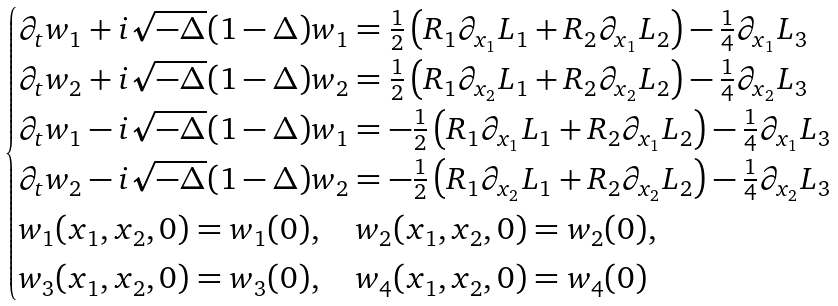<formula> <loc_0><loc_0><loc_500><loc_500>\begin{cases} \partial _ { t } w _ { 1 } + i \sqrt { - \Delta } ( 1 - \Delta ) w _ { 1 } = \frac { 1 } { 2 } \left ( R _ { 1 } \partial _ { x _ { 1 } } L _ { 1 } + R _ { 2 } \partial _ { x _ { 1 } } L _ { 2 } \right ) - \frac { 1 } { 4 } \partial _ { x _ { 1 } } L _ { 3 } \\ \partial _ { t } w _ { 2 } + i \sqrt { - \Delta } ( 1 - \Delta ) w _ { 2 } = \frac { 1 } { 2 } \left ( R _ { 1 } \partial _ { x _ { 2 } } L _ { 1 } + R _ { 2 } \partial _ { x _ { 2 } } L _ { 2 } \right ) - \frac { 1 } { 4 } \partial _ { x _ { 2 } } L _ { 3 } \\ \partial _ { t } w _ { 1 } - i \sqrt { - \Delta } ( 1 - \Delta ) w _ { 1 } = - \frac { 1 } { 2 } \left ( R _ { 1 } \partial _ { x _ { 1 } } L _ { 1 } + R _ { 2 } \partial _ { x _ { 1 } } L _ { 2 } \right ) - \frac { 1 } { 4 } \partial _ { x _ { 1 } } L _ { 3 } \\ \partial _ { t } w _ { 2 } - i \sqrt { - \Delta } ( 1 - \Delta ) w _ { 2 } = - \frac { 1 } { 2 } \left ( R _ { 1 } \partial _ { x _ { 2 } } L _ { 1 } + R _ { 2 } \partial _ { x _ { 2 } } L _ { 2 } \right ) - \frac { 1 } { 4 } \partial _ { x _ { 2 } } L _ { 3 } \\ w _ { 1 } ( x _ { 1 } , x _ { 2 } , 0 ) = w _ { 1 } ( 0 ) , \quad w _ { 2 } ( x _ { 1 } , x _ { 2 } , 0 ) = w _ { 2 } ( 0 ) , \\ w _ { 3 } ( x _ { 1 } , x _ { 2 } , 0 ) = w _ { 3 } ( 0 ) , \quad w _ { 4 } ( x _ { 1 } , x _ { 2 } , 0 ) = w _ { 4 } ( 0 ) \end{cases}</formula> 